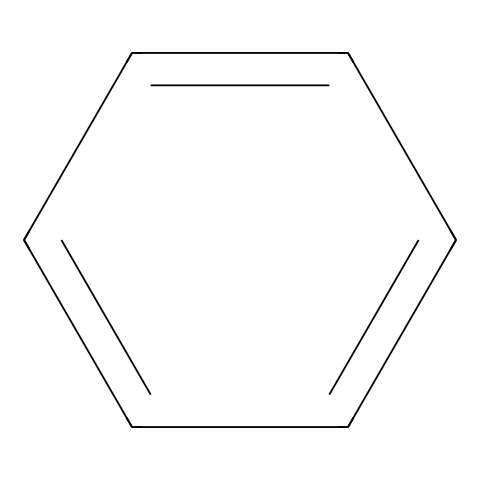What is the molecular formula of benzene? Benzene's SMILES representation c1ccccc1 indicates a ring structure with six carbon atoms and hydrogen atoms filling the remaining valences. The general molecular formula for benzene is C6H6.
Answer: C6H6 How many carbon atoms are present in benzene? The visualization from the SMILES code c1ccccc1 shows a hexagonal ring composed of six carbon atoms.
Answer: 6 What type of hybridization occurs in the carbon atoms of benzene? In benzene, each carbon atom forms three sigma bonds and one pi bond, which corresponds to sp2 hybridization. Thus, the hybridization of the carbon atoms is sp2.
Answer: sp2 Is benzene classified as a saturated or unsaturated compound? Benzene contains a ring structure with alternating double bonds, which indicates the presence of pi bonds. This means benzene is an unsaturated compound.
Answer: unsaturated What are the possible health effects of exposure to benzene? Benzene is known to be toxic and can cause various health issues, including cancer. Its exposure can lead to harmful effects on the bone marrow and immune system.
Answer: cancer What characteristic odor is associated with benzene? Benzene has a sweet, aromatic odor, which is a distinctive property of this volatile organic compound.
Answer: sweet What kind of reactions is benzene known to undergo? Benzene typically undergoes electrophilic substitution reactions, where substituents replace hydrogen atoms while maintaining the aromatic ring structure.
Answer: electrophilic substitution 